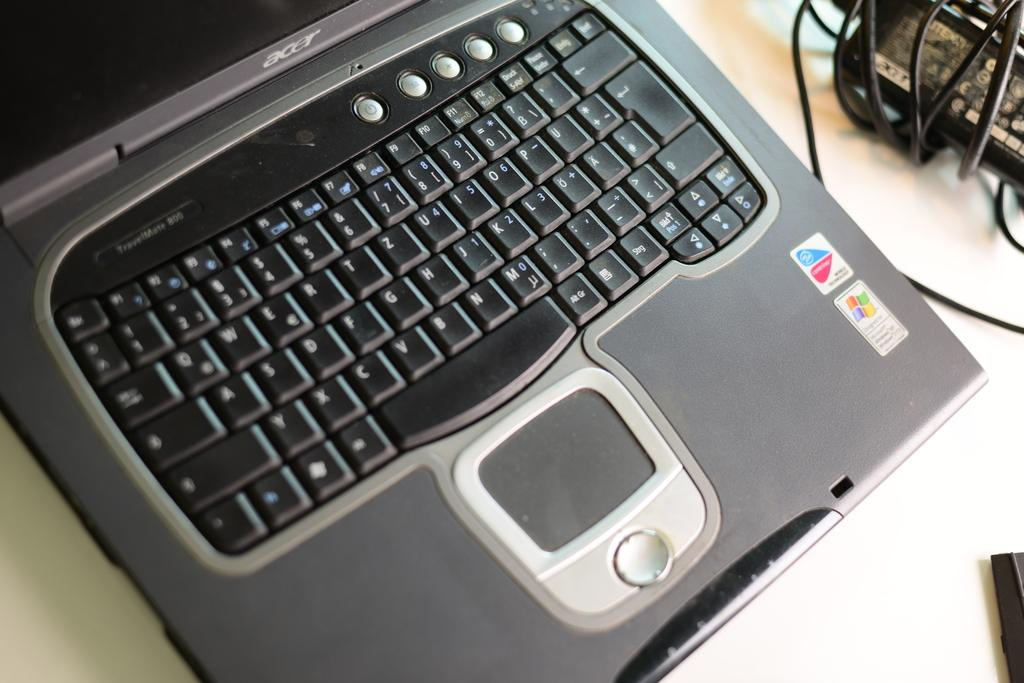<image>
Give a short and clear explanation of the subsequent image. The keyboard for a laptop that is running Microsoft Windows. 